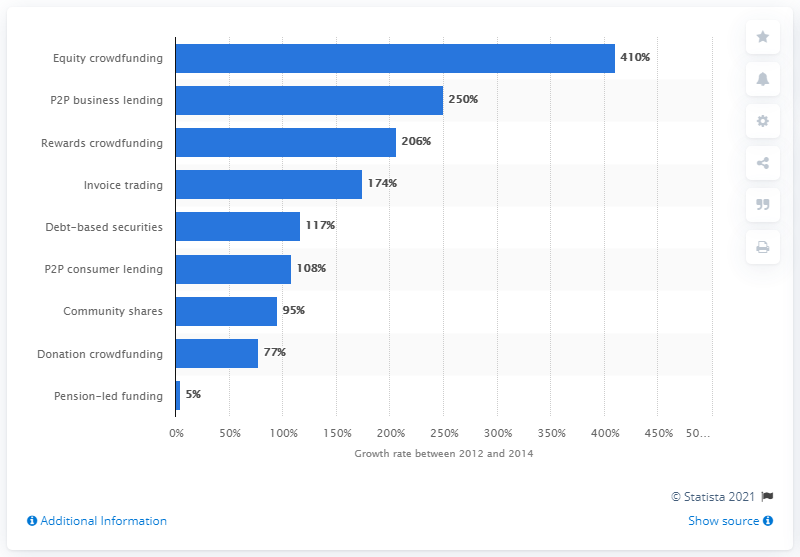Indicate a few pertinent items in this graphic. The market for equity crowdfunding platforms grew significantly between 2012 and 2014, with a growth rate of 410%. 